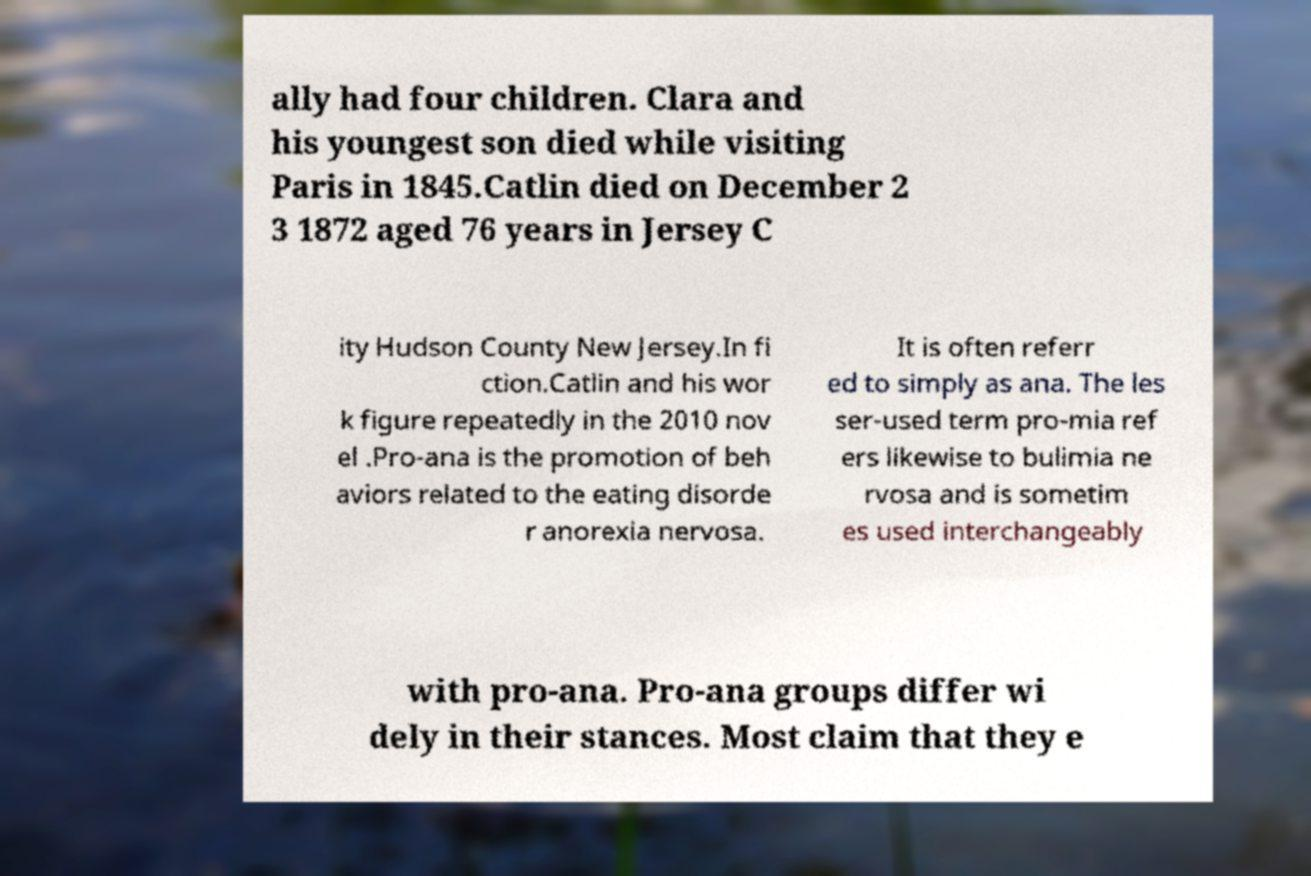Can you accurately transcribe the text from the provided image for me? ally had four children. Clara and his youngest son died while visiting Paris in 1845.Catlin died on December 2 3 1872 aged 76 years in Jersey C ity Hudson County New Jersey.In fi ction.Catlin and his wor k figure repeatedly in the 2010 nov el .Pro-ana is the promotion of beh aviors related to the eating disorde r anorexia nervosa. It is often referr ed to simply as ana. The les ser-used term pro-mia ref ers likewise to bulimia ne rvosa and is sometim es used interchangeably with pro-ana. Pro-ana groups differ wi dely in their stances. Most claim that they e 